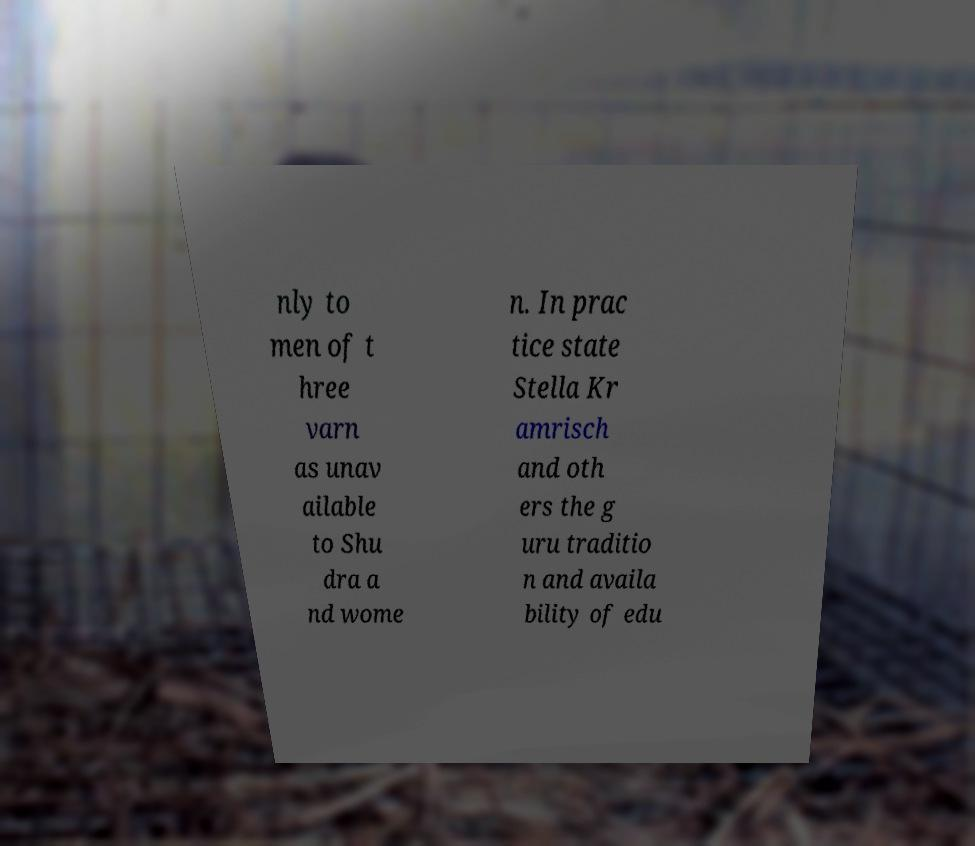Please read and relay the text visible in this image. What does it say? nly to men of t hree varn as unav ailable to Shu dra a nd wome n. In prac tice state Stella Kr amrisch and oth ers the g uru traditio n and availa bility of edu 